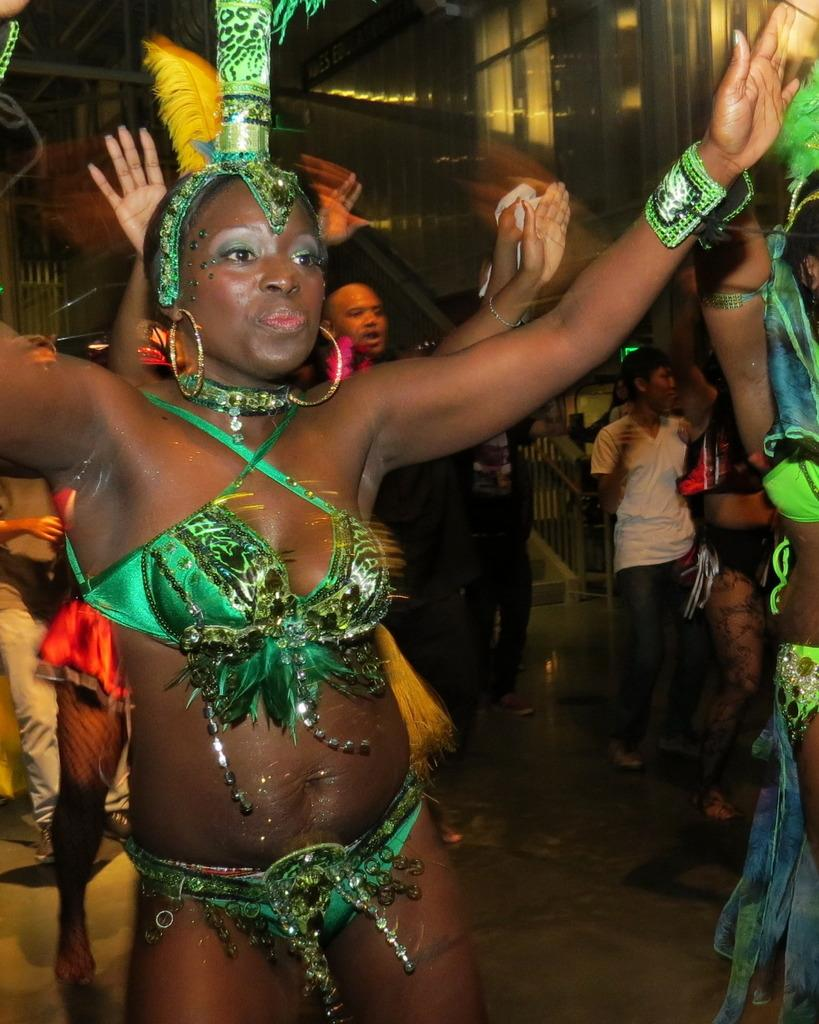How many people are in the image? There is a group of people in the image. What is the position of the people in the image? The people are standing on the ground. Can you describe the appearance of one of the individuals in the group? One girl is wearing a costume. What can be seen in the background of the image? There is a staircase and a building in the background of the image. What type of jam is being spread on the finger in the image? There is no jam or finger present in the image. 